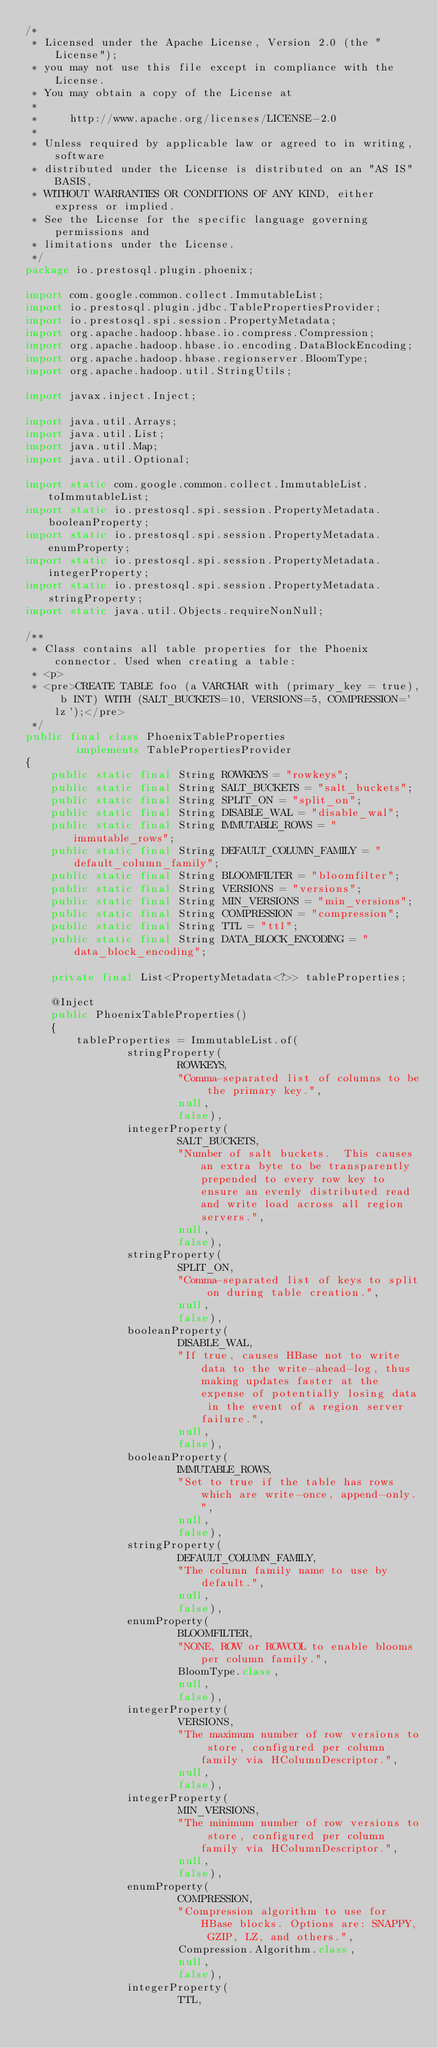Convert code to text. <code><loc_0><loc_0><loc_500><loc_500><_Java_>/*
 * Licensed under the Apache License, Version 2.0 (the "License");
 * you may not use this file except in compliance with the License.
 * You may obtain a copy of the License at
 *
 *     http://www.apache.org/licenses/LICENSE-2.0
 *
 * Unless required by applicable law or agreed to in writing, software
 * distributed under the License is distributed on an "AS IS" BASIS,
 * WITHOUT WARRANTIES OR CONDITIONS OF ANY KIND, either express or implied.
 * See the License for the specific language governing permissions and
 * limitations under the License.
 */
package io.prestosql.plugin.phoenix;

import com.google.common.collect.ImmutableList;
import io.prestosql.plugin.jdbc.TablePropertiesProvider;
import io.prestosql.spi.session.PropertyMetadata;
import org.apache.hadoop.hbase.io.compress.Compression;
import org.apache.hadoop.hbase.io.encoding.DataBlockEncoding;
import org.apache.hadoop.hbase.regionserver.BloomType;
import org.apache.hadoop.util.StringUtils;

import javax.inject.Inject;

import java.util.Arrays;
import java.util.List;
import java.util.Map;
import java.util.Optional;

import static com.google.common.collect.ImmutableList.toImmutableList;
import static io.prestosql.spi.session.PropertyMetadata.booleanProperty;
import static io.prestosql.spi.session.PropertyMetadata.enumProperty;
import static io.prestosql.spi.session.PropertyMetadata.integerProperty;
import static io.prestosql.spi.session.PropertyMetadata.stringProperty;
import static java.util.Objects.requireNonNull;

/**
 * Class contains all table properties for the Phoenix connector. Used when creating a table:
 * <p>
 * <pre>CREATE TABLE foo (a VARCHAR with (primary_key = true), b INT) WITH (SALT_BUCKETS=10, VERSIONS=5, COMPRESSION='lz');</pre>
 */
public final class PhoenixTableProperties
        implements TablePropertiesProvider
{
    public static final String ROWKEYS = "rowkeys";
    public static final String SALT_BUCKETS = "salt_buckets";
    public static final String SPLIT_ON = "split_on";
    public static final String DISABLE_WAL = "disable_wal";
    public static final String IMMUTABLE_ROWS = "immutable_rows";
    public static final String DEFAULT_COLUMN_FAMILY = "default_column_family";
    public static final String BLOOMFILTER = "bloomfilter";
    public static final String VERSIONS = "versions";
    public static final String MIN_VERSIONS = "min_versions";
    public static final String COMPRESSION = "compression";
    public static final String TTL = "ttl";
    public static final String DATA_BLOCK_ENCODING = "data_block_encoding";

    private final List<PropertyMetadata<?>> tableProperties;

    @Inject
    public PhoenixTableProperties()
    {
        tableProperties = ImmutableList.of(
                stringProperty(
                        ROWKEYS,
                        "Comma-separated list of columns to be the primary key.",
                        null,
                        false),
                integerProperty(
                        SALT_BUCKETS,
                        "Number of salt buckets.  This causes an extra byte to be transparently prepended to every row key to ensure an evenly distributed read and write load across all region servers.",
                        null,
                        false),
                stringProperty(
                        SPLIT_ON,
                        "Comma-separated list of keys to split on during table creation.",
                        null,
                        false),
                booleanProperty(
                        DISABLE_WAL,
                        "If true, causes HBase not to write data to the write-ahead-log, thus making updates faster at the expense of potentially losing data in the event of a region server failure.",
                        null,
                        false),
                booleanProperty(
                        IMMUTABLE_ROWS,
                        "Set to true if the table has rows which are write-once, append-only.",
                        null,
                        false),
                stringProperty(
                        DEFAULT_COLUMN_FAMILY,
                        "The column family name to use by default.",
                        null,
                        false),
                enumProperty(
                        BLOOMFILTER,
                        "NONE, ROW or ROWCOL to enable blooms per column family.",
                        BloomType.class,
                        null,
                        false),
                integerProperty(
                        VERSIONS,
                        "The maximum number of row versions to store, configured per column family via HColumnDescriptor.",
                        null,
                        false),
                integerProperty(
                        MIN_VERSIONS,
                        "The minimum number of row versions to store, configured per column family via HColumnDescriptor.",
                        null,
                        false),
                enumProperty(
                        COMPRESSION,
                        "Compression algorithm to use for HBase blocks. Options are: SNAPPY, GZIP, LZ, and others.",
                        Compression.Algorithm.class,
                        null,
                        false),
                integerProperty(
                        TTL,</code> 